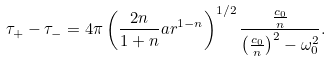Convert formula to latex. <formula><loc_0><loc_0><loc_500><loc_500>\tau _ { + } - \tau _ { - } = 4 \pi \left ( \frac { 2 n } { 1 + n } a r ^ { 1 - n } \right ) ^ { 1 / 2 } \frac { \frac { c _ { 0 } } { n } } { \left ( \frac { c _ { 0 } } { n } \right ) ^ { 2 } - \omega _ { 0 } ^ { 2 } } .</formula> 